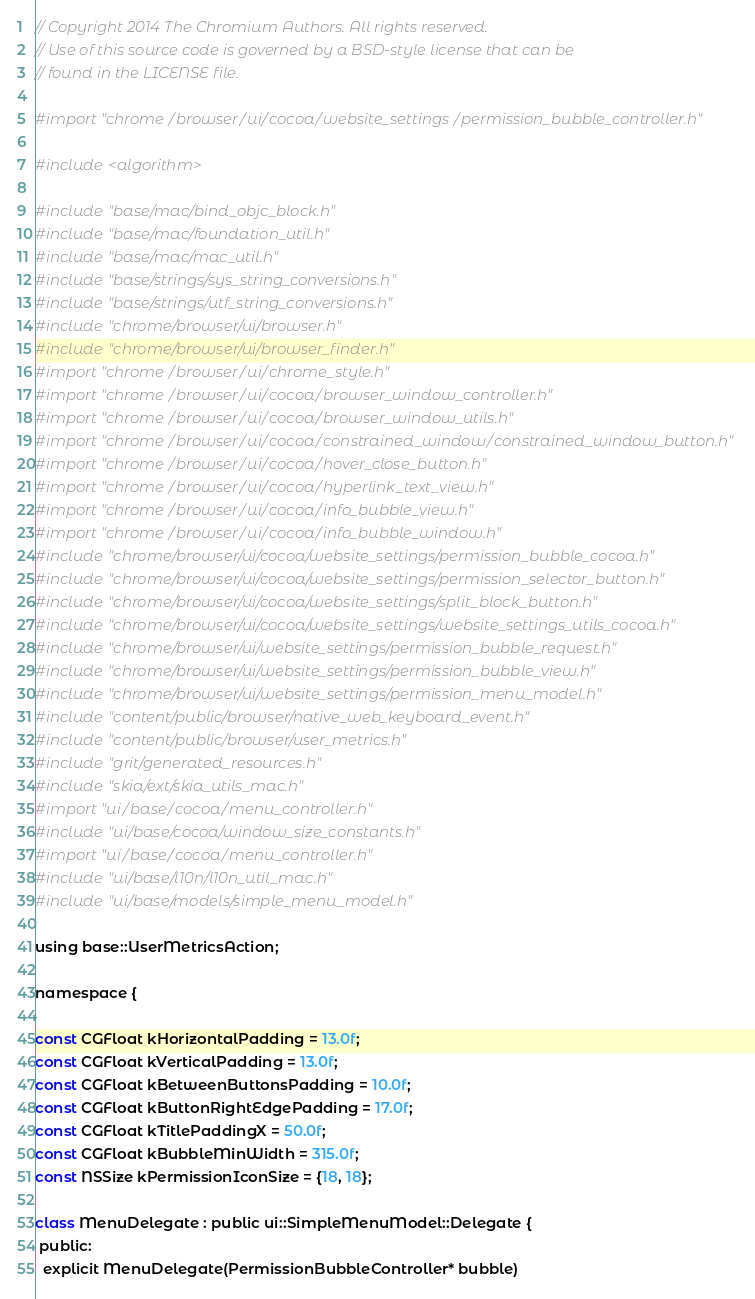<code> <loc_0><loc_0><loc_500><loc_500><_ObjectiveC_>// Copyright 2014 The Chromium Authors. All rights reserved.
// Use of this source code is governed by a BSD-style license that can be
// found in the LICENSE file.

#import "chrome/browser/ui/cocoa/website_settings/permission_bubble_controller.h"

#include <algorithm>

#include "base/mac/bind_objc_block.h"
#include "base/mac/foundation_util.h"
#include "base/mac/mac_util.h"
#include "base/strings/sys_string_conversions.h"
#include "base/strings/utf_string_conversions.h"
#include "chrome/browser/ui/browser.h"
#include "chrome/browser/ui/browser_finder.h"
#import "chrome/browser/ui/chrome_style.h"
#import "chrome/browser/ui/cocoa/browser_window_controller.h"
#import "chrome/browser/ui/cocoa/browser_window_utils.h"
#import "chrome/browser/ui/cocoa/constrained_window/constrained_window_button.h"
#import "chrome/browser/ui/cocoa/hover_close_button.h"
#import "chrome/browser/ui/cocoa/hyperlink_text_view.h"
#import "chrome/browser/ui/cocoa/info_bubble_view.h"
#import "chrome/browser/ui/cocoa/info_bubble_window.h"
#include "chrome/browser/ui/cocoa/website_settings/permission_bubble_cocoa.h"
#include "chrome/browser/ui/cocoa/website_settings/permission_selector_button.h"
#include "chrome/browser/ui/cocoa/website_settings/split_block_button.h"
#include "chrome/browser/ui/cocoa/website_settings/website_settings_utils_cocoa.h"
#include "chrome/browser/ui/website_settings/permission_bubble_request.h"
#include "chrome/browser/ui/website_settings/permission_bubble_view.h"
#include "chrome/browser/ui/website_settings/permission_menu_model.h"
#include "content/public/browser/native_web_keyboard_event.h"
#include "content/public/browser/user_metrics.h"
#include "grit/generated_resources.h"
#include "skia/ext/skia_utils_mac.h"
#import "ui/base/cocoa/menu_controller.h"
#include "ui/base/cocoa/window_size_constants.h"
#import "ui/base/cocoa/menu_controller.h"
#include "ui/base/l10n/l10n_util_mac.h"
#include "ui/base/models/simple_menu_model.h"

using base::UserMetricsAction;

namespace {

const CGFloat kHorizontalPadding = 13.0f;
const CGFloat kVerticalPadding = 13.0f;
const CGFloat kBetweenButtonsPadding = 10.0f;
const CGFloat kButtonRightEdgePadding = 17.0f;
const CGFloat kTitlePaddingX = 50.0f;
const CGFloat kBubbleMinWidth = 315.0f;
const NSSize kPermissionIconSize = {18, 18};

class MenuDelegate : public ui::SimpleMenuModel::Delegate {
 public:
  explicit MenuDelegate(PermissionBubbleController* bubble)</code> 